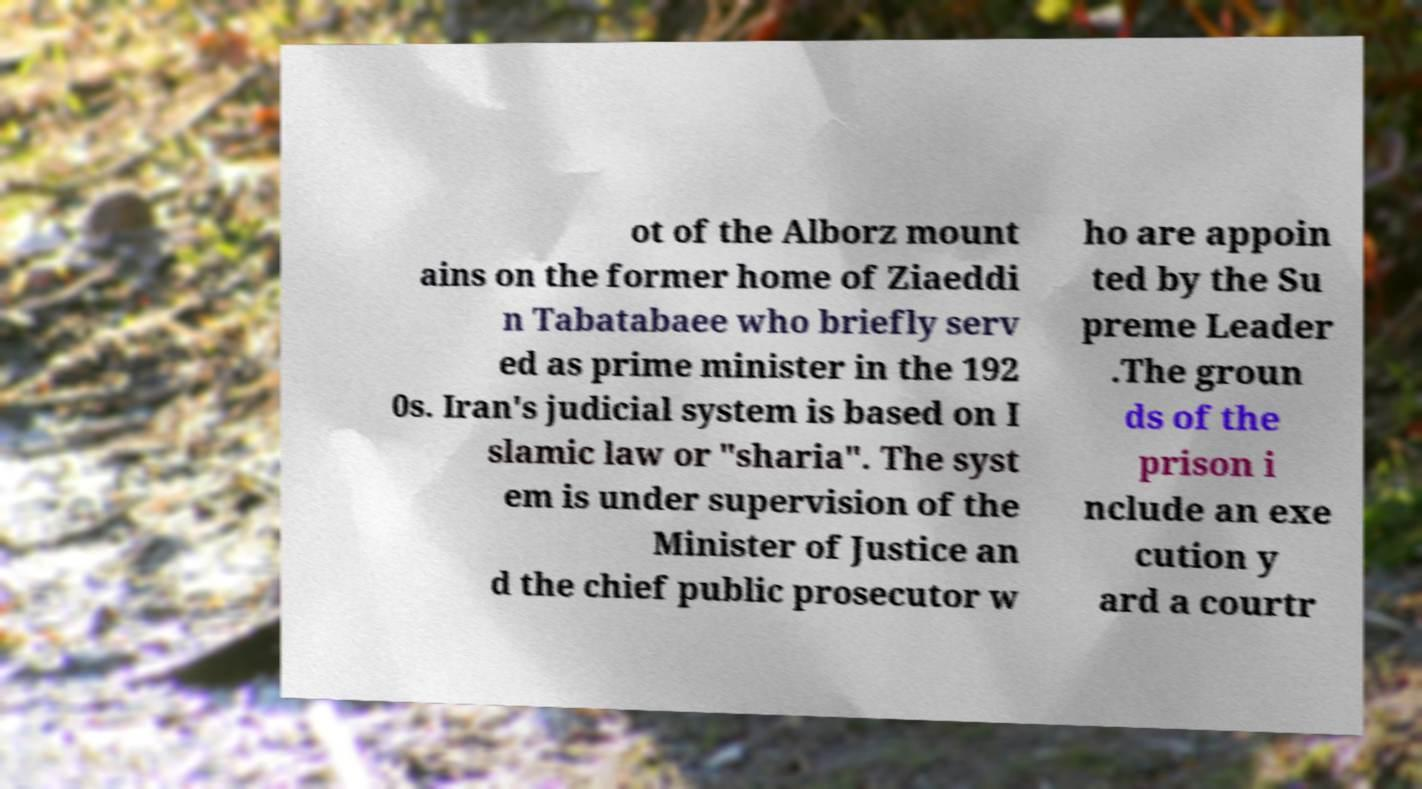There's text embedded in this image that I need extracted. Can you transcribe it verbatim? ot of the Alborz mount ains on the former home of Ziaeddi n Tabatabaee who briefly serv ed as prime minister in the 192 0s. Iran's judicial system is based on I slamic law or "sharia". The syst em is under supervision of the Minister of Justice an d the chief public prosecutor w ho are appoin ted by the Su preme Leader .The groun ds of the prison i nclude an exe cution y ard a courtr 